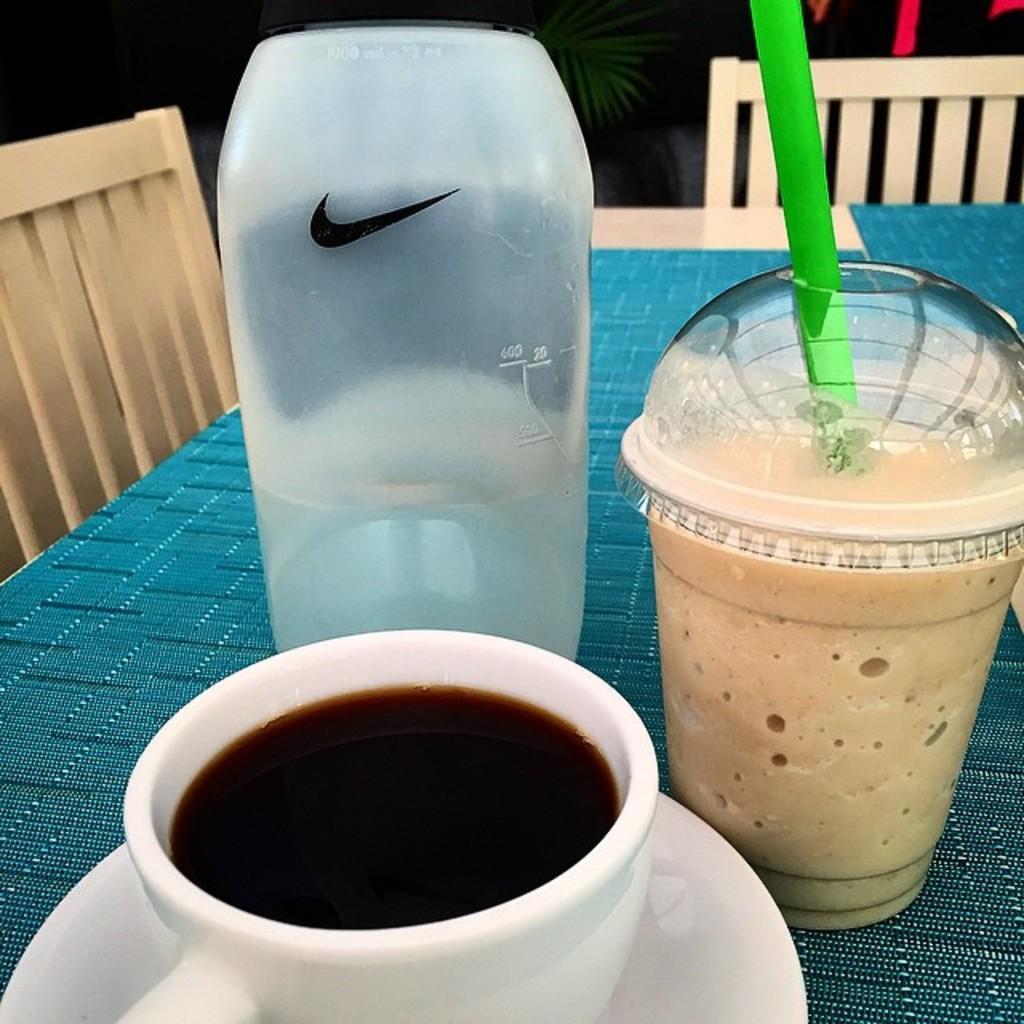Can you describe this image briefly? In front of the picture, we see a blue color table on which water bottle, cup, saucer, cup containing liquid and straw are placed. Beside that, we see two chairs. In the background, it is black in color. 